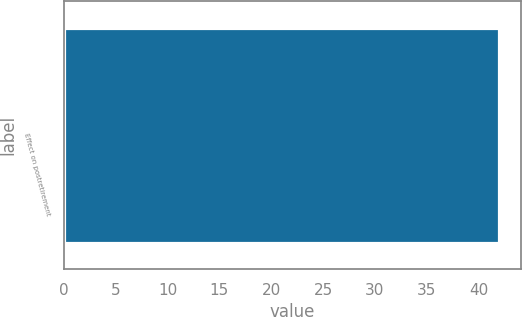Convert chart. <chart><loc_0><loc_0><loc_500><loc_500><bar_chart><fcel>Effect on postretirement<nl><fcel>42<nl></chart> 